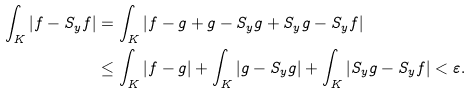Convert formula to latex. <formula><loc_0><loc_0><loc_500><loc_500>\int _ { K } | f - S _ { y } f | & = \int _ { K } | f - g + g - S _ { y } g + S _ { y } g - S _ { y } f | \\ & \leq \int _ { K } | f - g | + \int _ { K } | g - S _ { y } g | + \int _ { K } | S _ { y } g - S _ { y } f | < \varepsilon .</formula> 